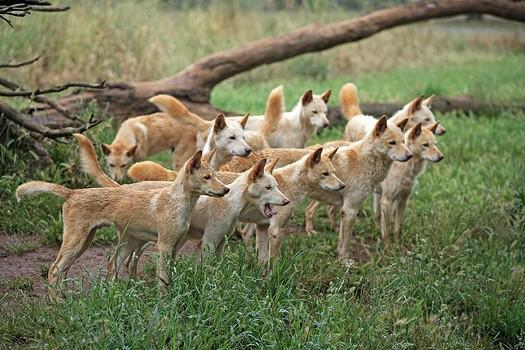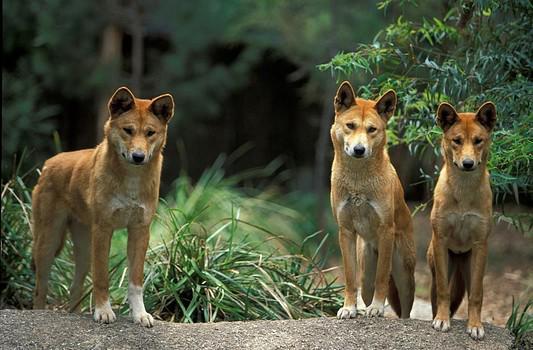The first image is the image on the left, the second image is the image on the right. For the images shown, is this caption "There's no more than one wild dog in the right image." true? Answer yes or no. No. The first image is the image on the left, the second image is the image on the right. Assess this claim about the two images: "There are more animals in the left image than there are in the right image.". Correct or not? Answer yes or no. Yes. 